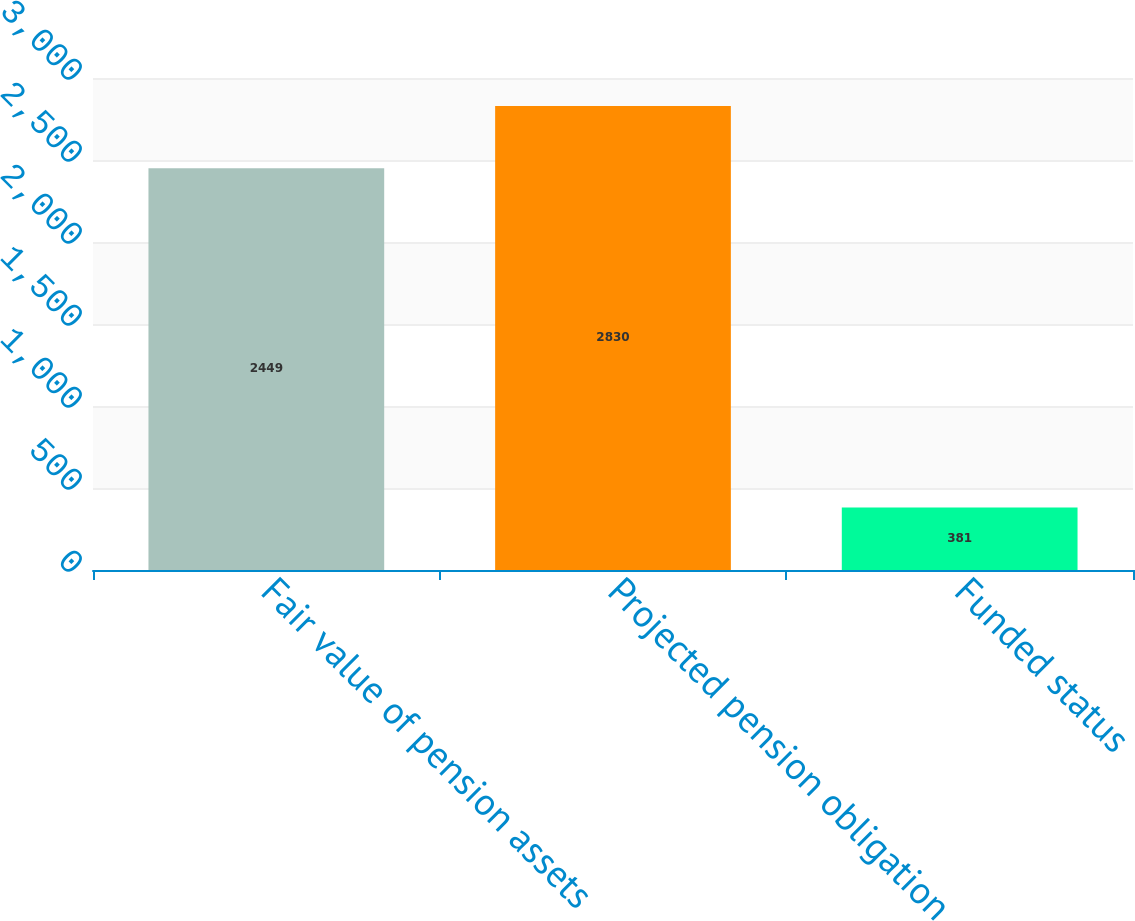<chart> <loc_0><loc_0><loc_500><loc_500><bar_chart><fcel>Fair value of pension assets<fcel>Projected pension obligation<fcel>Funded status<nl><fcel>2449<fcel>2830<fcel>381<nl></chart> 